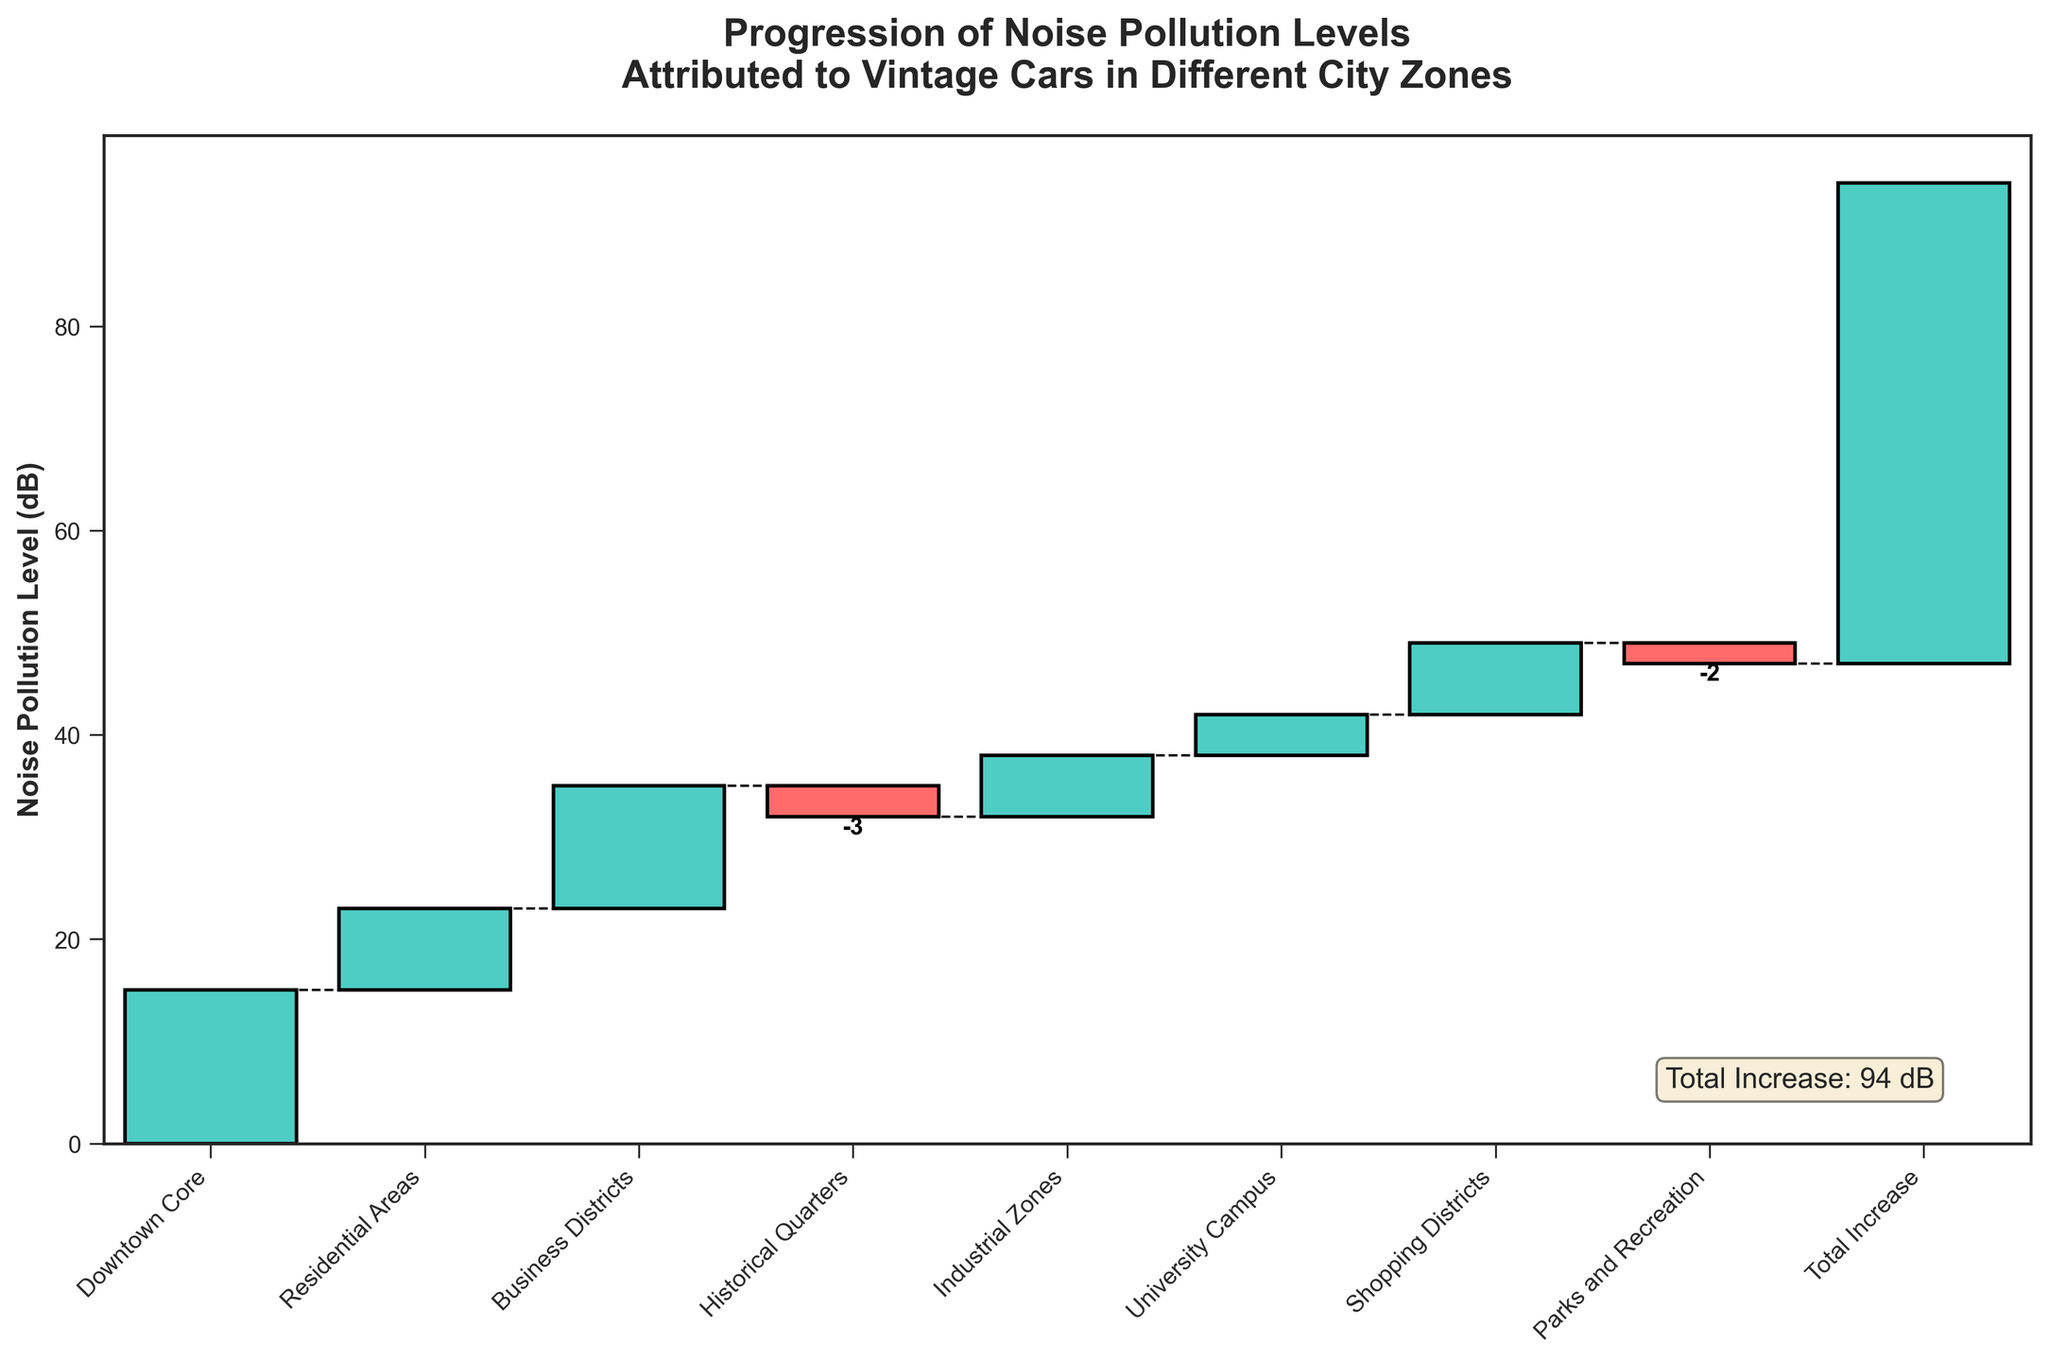what is the title of the chart? The title is typically shown prominently at the top of the chart. Here, it is "Progression of Noise Pollution Levels Attributed to Vintage Cars in Different City Zones".
Answer: Progression of Noise Pollution Levels Attributed to Vintage Cars in Different City Zones Which city zone contributes the most to noise pollution? By examining the heights of the bars, the tallest positive bar represents the Downtown Core, which has a value of 15 dB.
Answer: Downtown Core How does the noise pollution level in Historical Quarters compare to that in Parks and Recreation? Both of these zones have negative values, indicating a decrease in noise pollution levels. Historical Quarters is -3 dB and Parks and Recreation is -2 dB. Since -3 is less than -2, Historical Quarters has a greater reduction.
Answer: Historical Quarters has a greater reduction What is the total increase in noise pollution levels? The total increase is usually indicated as an aggregated value at the end of the bars and marked separately. Here, it states "Total Increase: 47 dB".
Answer: 47 dB What are the zones with a decrease in noise pollution? Negative values indicate a decrease. By examining the bars, Historical Quarters (-3 dB) and Parks and Recreation (-2 dB) show decreases.
Answer: Historical Quarters and Parks and Recreation Which zone has contributed the least to the noise pollution levels? The value with the smallest positive number contributes the least. Here, the University Campus has the smallest positive value (4 dB).
Answer: University Campus If we sum the noise pollution levels of the Business Districts and Industrial Zones, what do we get? The values for Business Districts and Industrial Zones are 12 dB and 6 dB respectively. Summing these up gives 12 + 6.
Answer: 18 dB What is the difference between the noise pollution levels in Residential Areas and Shopping Districts? The value for Residential Areas is 8 dB and for Shopping Districts is 7 dB. The difference is calculated as 8 - 7.
Answer: 1 dB 